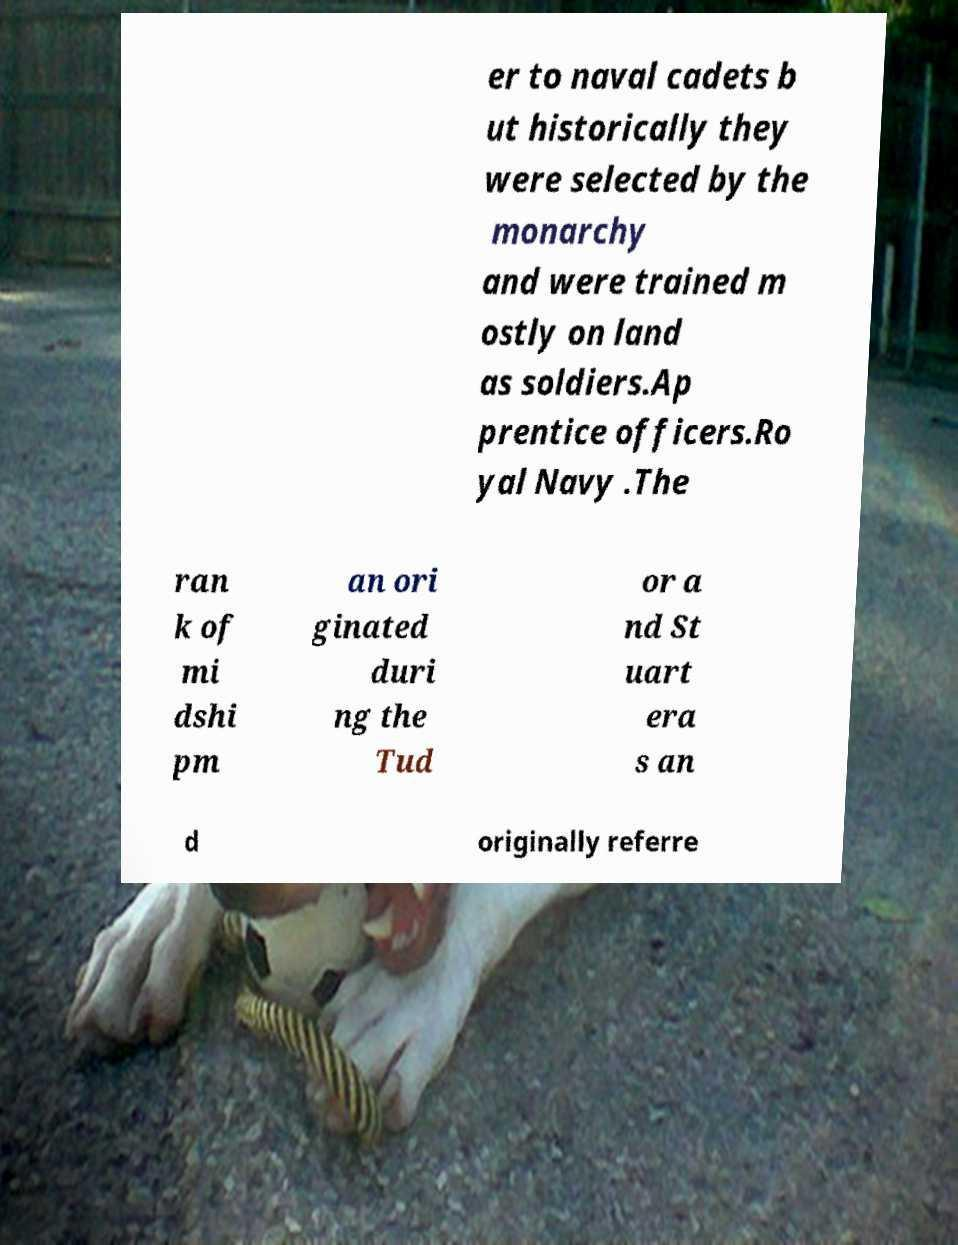Please identify and transcribe the text found in this image. er to naval cadets b ut historically they were selected by the monarchy and were trained m ostly on land as soldiers.Ap prentice officers.Ro yal Navy .The ran k of mi dshi pm an ori ginated duri ng the Tud or a nd St uart era s an d originally referre 